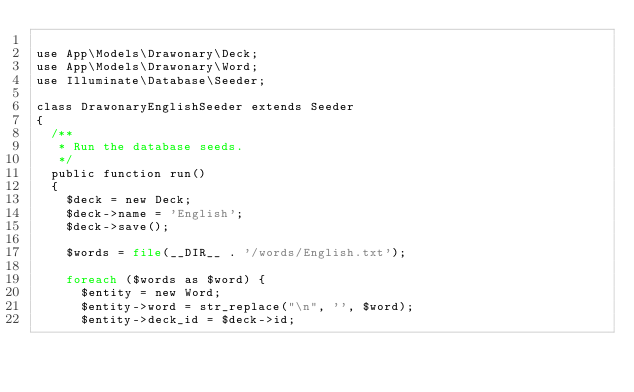<code> <loc_0><loc_0><loc_500><loc_500><_PHP_>
use App\Models\Drawonary\Deck;
use App\Models\Drawonary\Word;
use Illuminate\Database\Seeder;

class DrawonaryEnglishSeeder extends Seeder
{
	/**
	 * Run the database seeds.
	 */
	public function run()
	{
		$deck = new Deck;
		$deck->name = 'English';
		$deck->save();

		$words = file(__DIR__ . '/words/English.txt');

		foreach ($words as $word) {
			$entity = new Word;
			$entity->word = str_replace("\n", '', $word);
			$entity->deck_id = $deck->id;</code> 